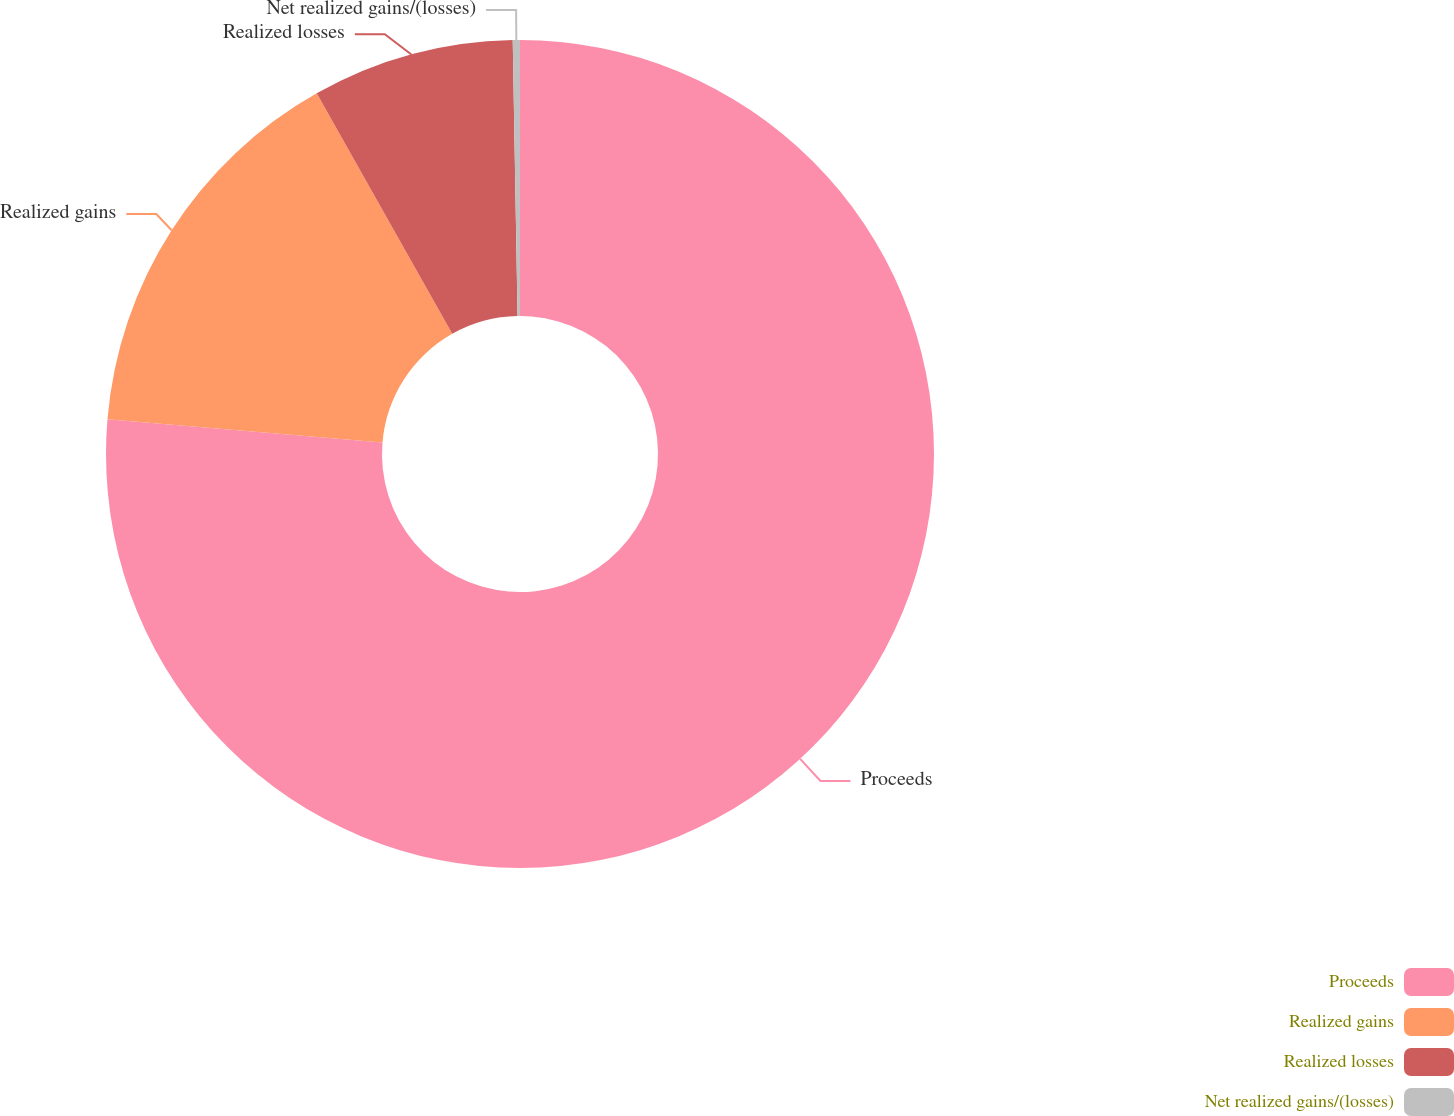<chart> <loc_0><loc_0><loc_500><loc_500><pie_chart><fcel>Proceeds<fcel>Realized gains<fcel>Realized losses<fcel>Net realized gains/(losses)<nl><fcel>76.34%<fcel>15.49%<fcel>7.89%<fcel>0.28%<nl></chart> 